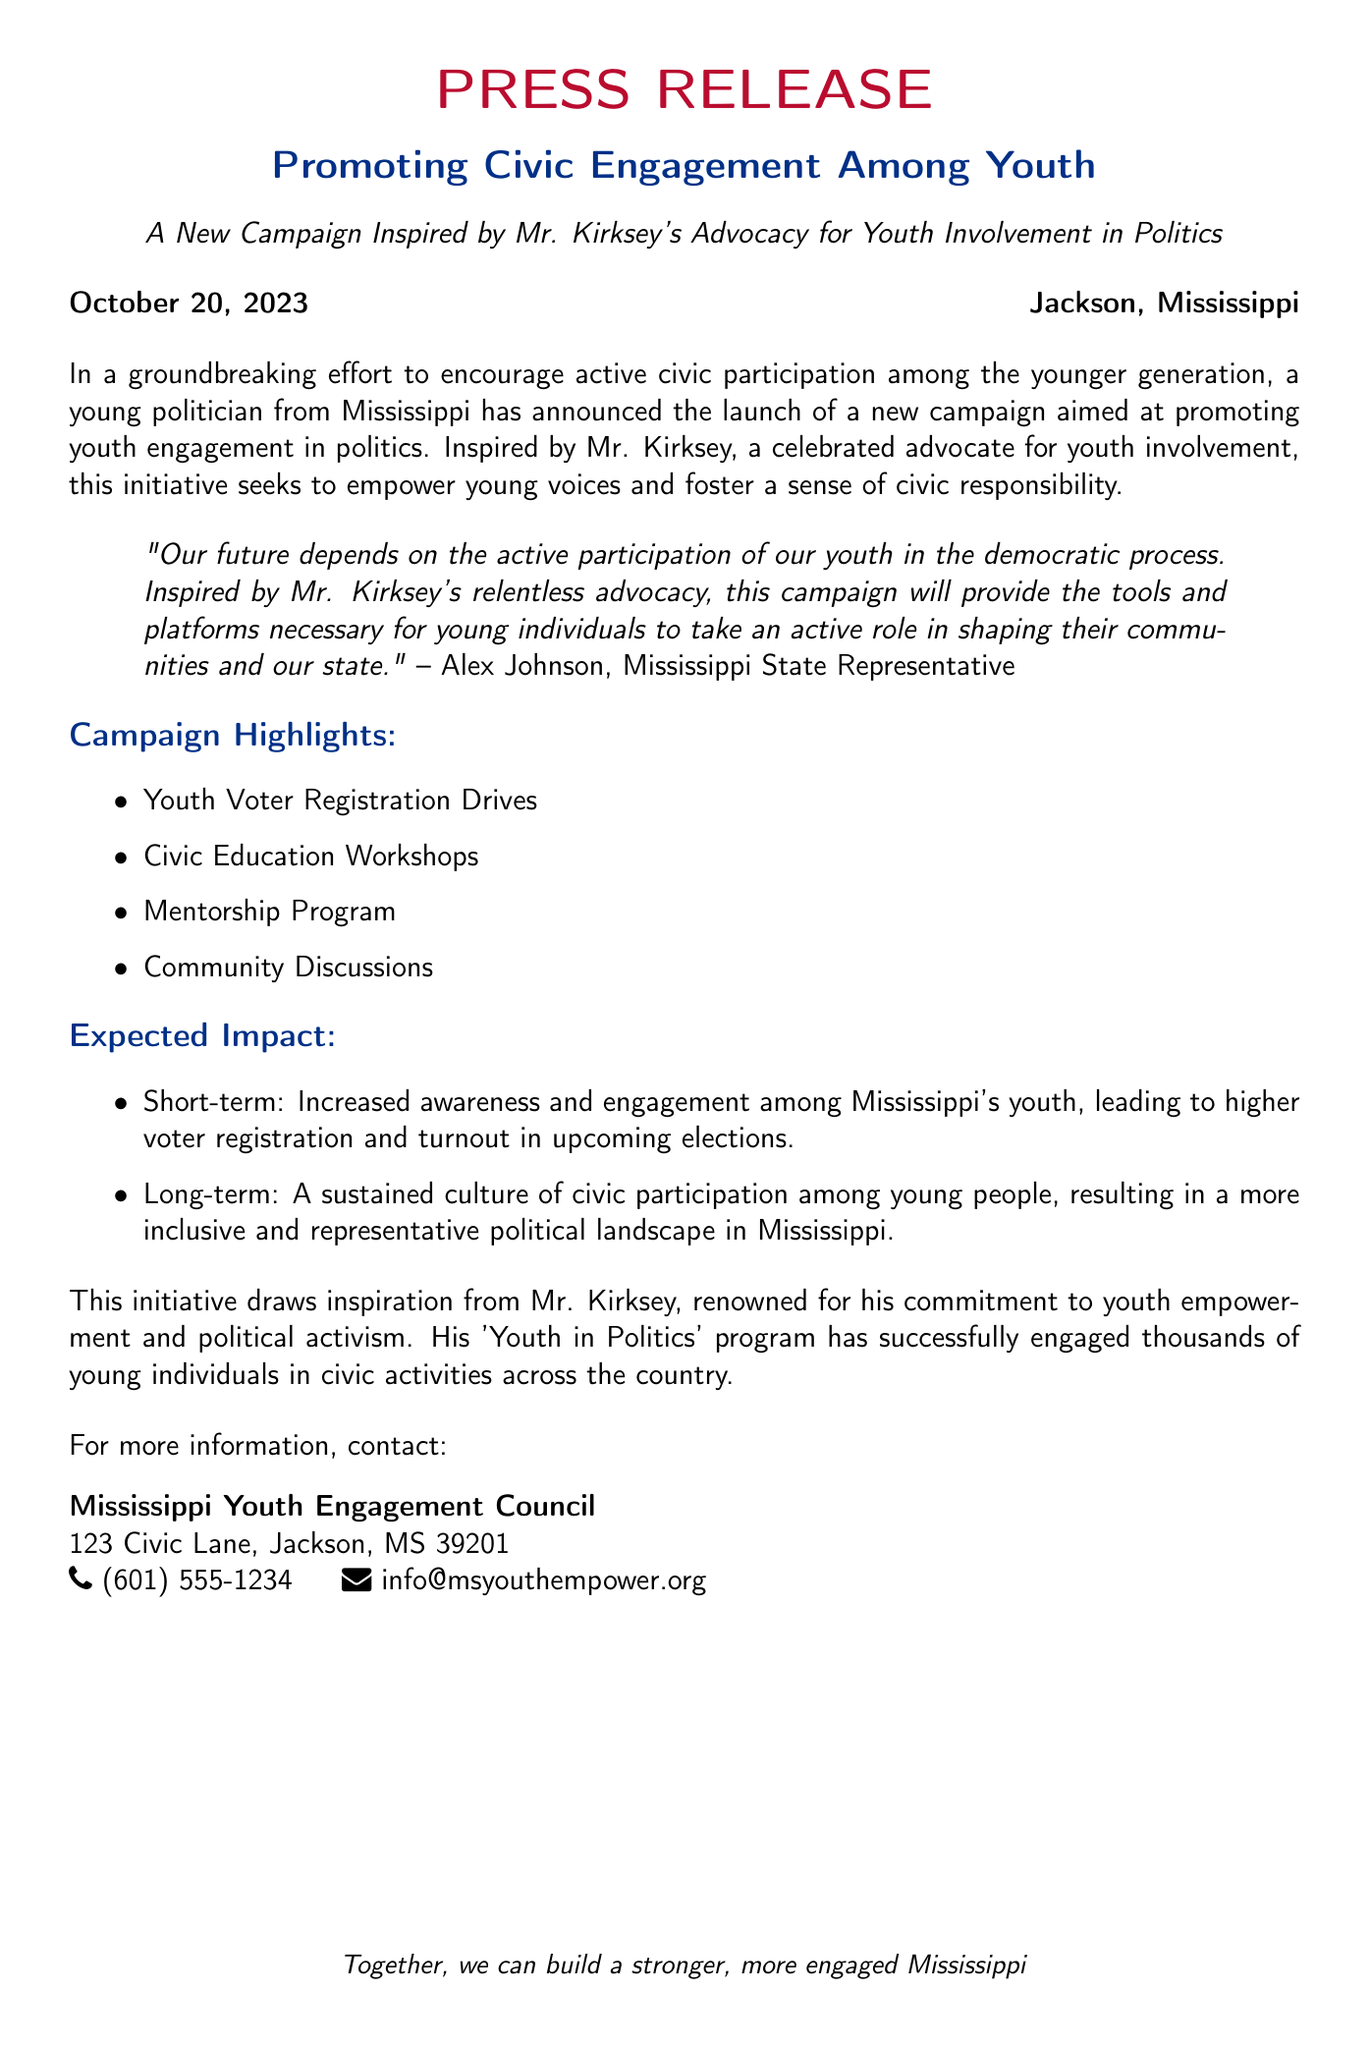What is the title of the campaign? The document titles the campaign as "Promoting Civic Engagement Among Youth".
Answer: Promoting Civic Engagement Among Youth Who announced the campaign? The campaign was announced by Alex Johnson, a Mississippi State Representative.
Answer: Alex Johnson What date was the press release issued? The press release was issued on October 20, 2023.
Answer: October 20, 2023 What is one of the expected short-term impacts of the campaign? One expected short-term impact is increased awareness and engagement among Mississippi's youth.
Answer: Increased awareness and engagement Which organization can be contacted for more information about the campaign? The Mississippi Youth Engagement Council is the organization to contact for more information.
Answer: Mississippi Youth Engagement Council What does the campaign aim to foster among young individuals? The campaign aims to foster a sense of civic responsibility among young individuals.
Answer: Civic responsibility What program inspired the initiative mentioned in the document? The initiative is inspired by Mr. Kirksey's 'Youth in Politics' program.
Answer: Youth in Politics What type of workshops will the campaign provide? The campaign will provide civic education workshops.
Answer: Civic education workshops 